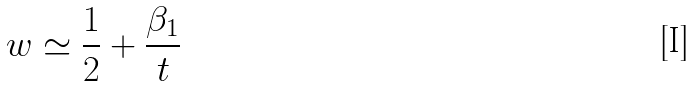<formula> <loc_0><loc_0><loc_500><loc_500>w \simeq \frac { 1 } { 2 } + \frac { \beta _ { 1 } } { t }</formula> 